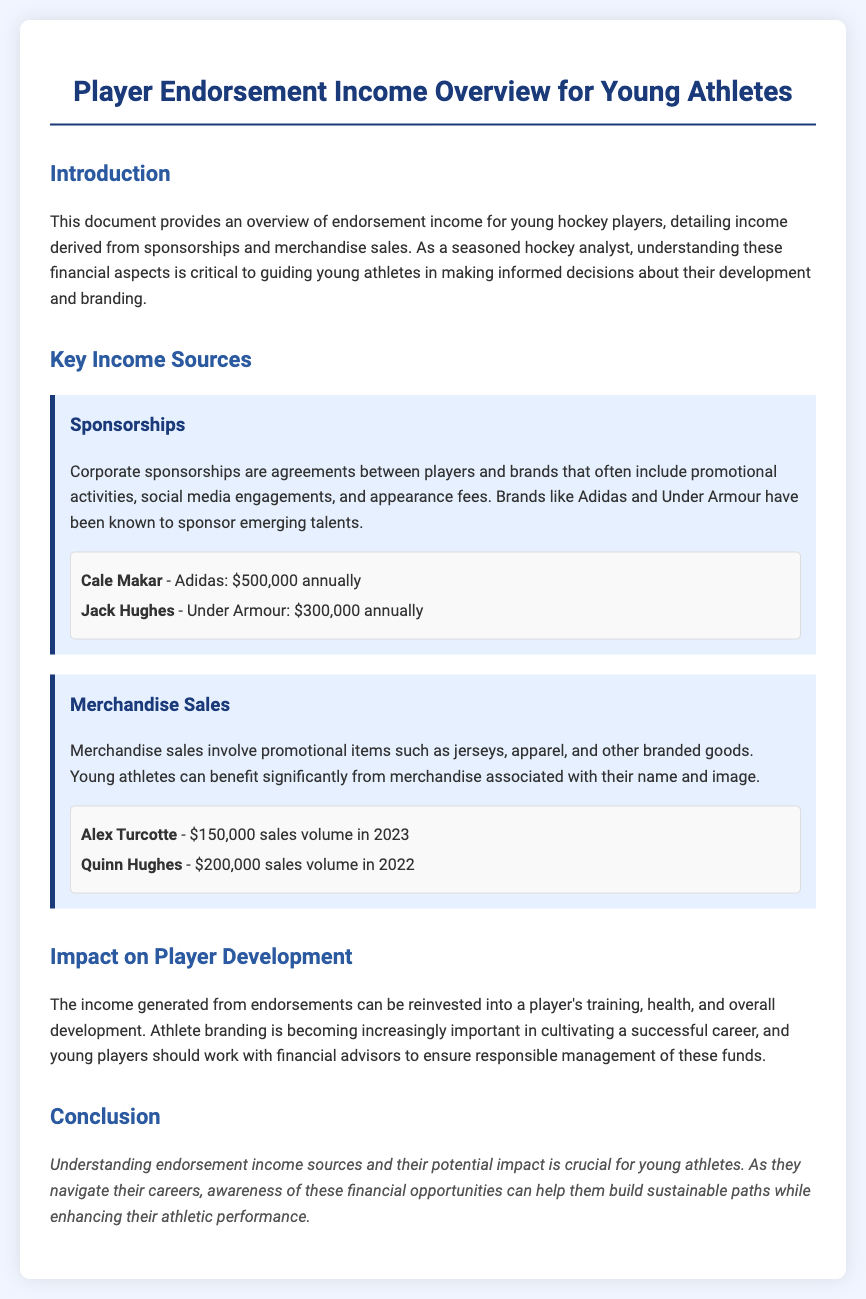What is the primary focus of the document? The document provides an overview of endorsement income for young hockey players from sponsorships and merchandise sales.
Answer: Endorsement income Who sponsors Cale Makar? Cale Makar has a sponsorship agreement with Adidas.
Answer: Adidas What is Jack Hughes' annual sponsorship income? The annual sponsorship income for Jack Hughes from Under Armour is stated in the document.
Answer: $300,000 What was Alex Turcotte's merchandise sales volume in 2023? The document lists the sales volume for Alex Turcotte specifically in 2023.
Answer: $150,000 How can endorsement income be reinvested according to the document? It mentions that income generated from endorsements can be reinvested into training, health, and overall development.
Answer: Training, health, overall development Why is athlete branding important? The document explains that athlete branding is crucial for cultivating a successful career and enhancing athletic performance.
Answer: Cultivating a successful career How many primary income sources are identified in the document? The document identifies two primary income sources for young athletes.
Answer: Two What should young players do with their endorsement income? The document suggests that young players should work with financial advisors to manage their endorsement income responsibly.
Answer: Work with financial advisors 